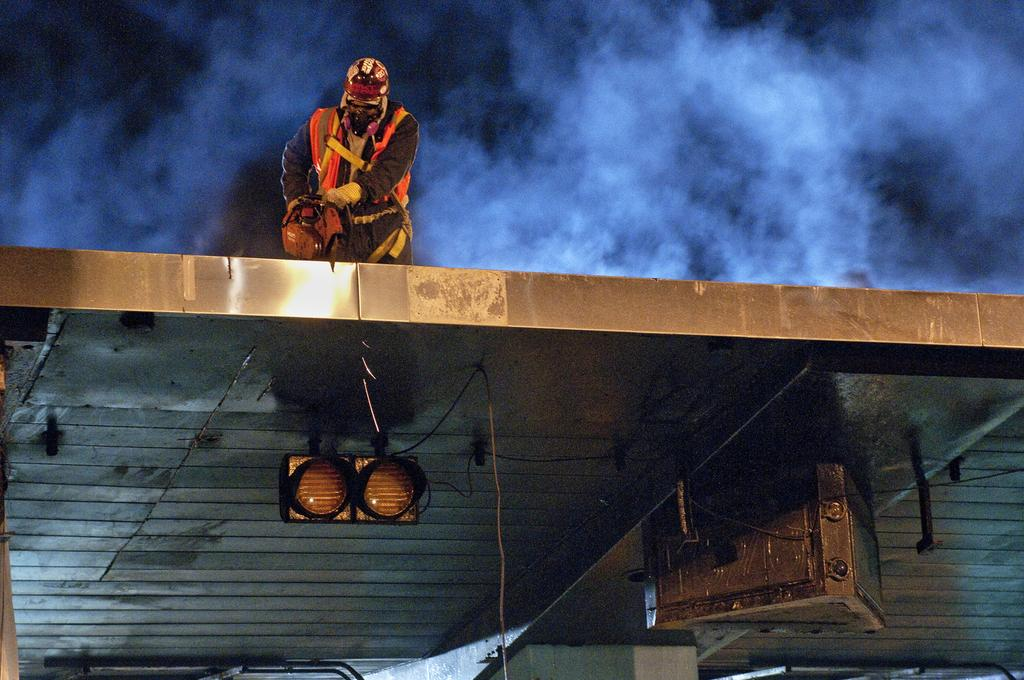What is the person in the image doing? There is a person standing on the roof in the image. What is the person holding in his hand? The person is holding an object in his hand. Can you describe any other objects visible in the image? Yes, there are objects visible in the image. What type of light can be seen in the image? There is a light in the image. What can be observed in the background of the image? There is smoke in the background of the image. Can you tell me how the person is swimming in the image? There is no swimming activity depicted in the image; the person is standing on the roof. 